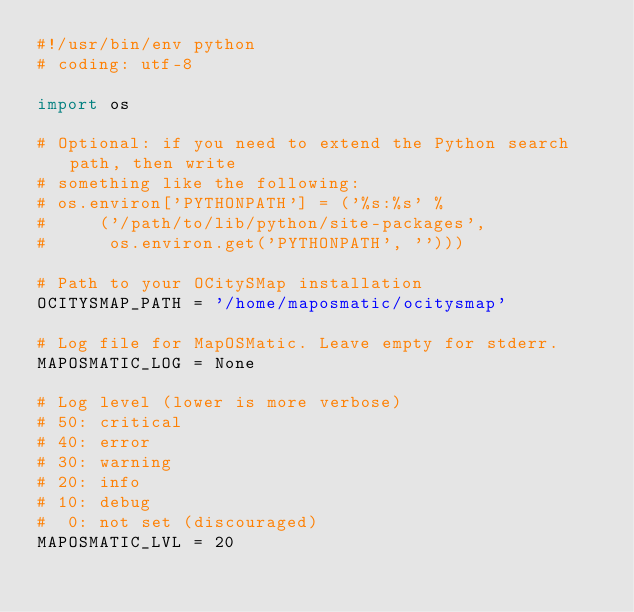Convert code to text. <code><loc_0><loc_0><loc_500><loc_500><_Python_>#!/usr/bin/env python
# coding: utf-8

import os

# Optional: if you need to extend the Python search path, then write
# something like the following:
# os.environ['PYTHONPATH'] = ('%s:%s' %
#     ('/path/to/lib/python/site-packages',
#      os.environ.get('PYTHONPATH', '')))

# Path to your OCitySMap installation
OCITYSMAP_PATH = '/home/maposmatic/ocitysmap'

# Log file for MapOSMatic. Leave empty for stderr.
MAPOSMATIC_LOG = None

# Log level (lower is more verbose)
# 50: critical
# 40: error
# 30: warning
# 20: info
# 10: debug
#  0: not set (discouraged)
MAPOSMATIC_LVL = 20
</code> 